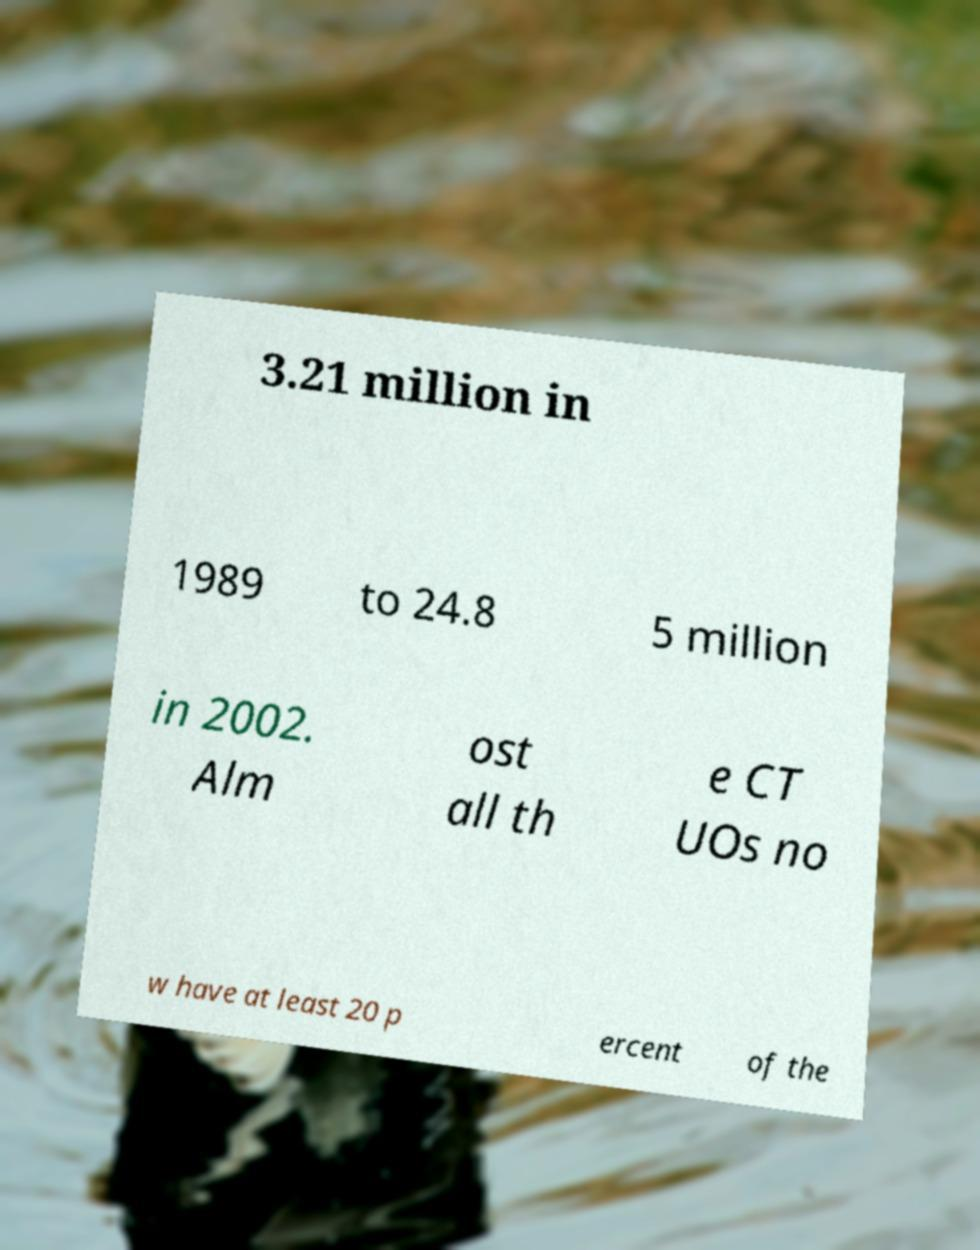I need the written content from this picture converted into text. Can you do that? 3.21 million in 1989 to 24.8 5 million in 2002. Alm ost all th e CT UOs no w have at least 20 p ercent of the 